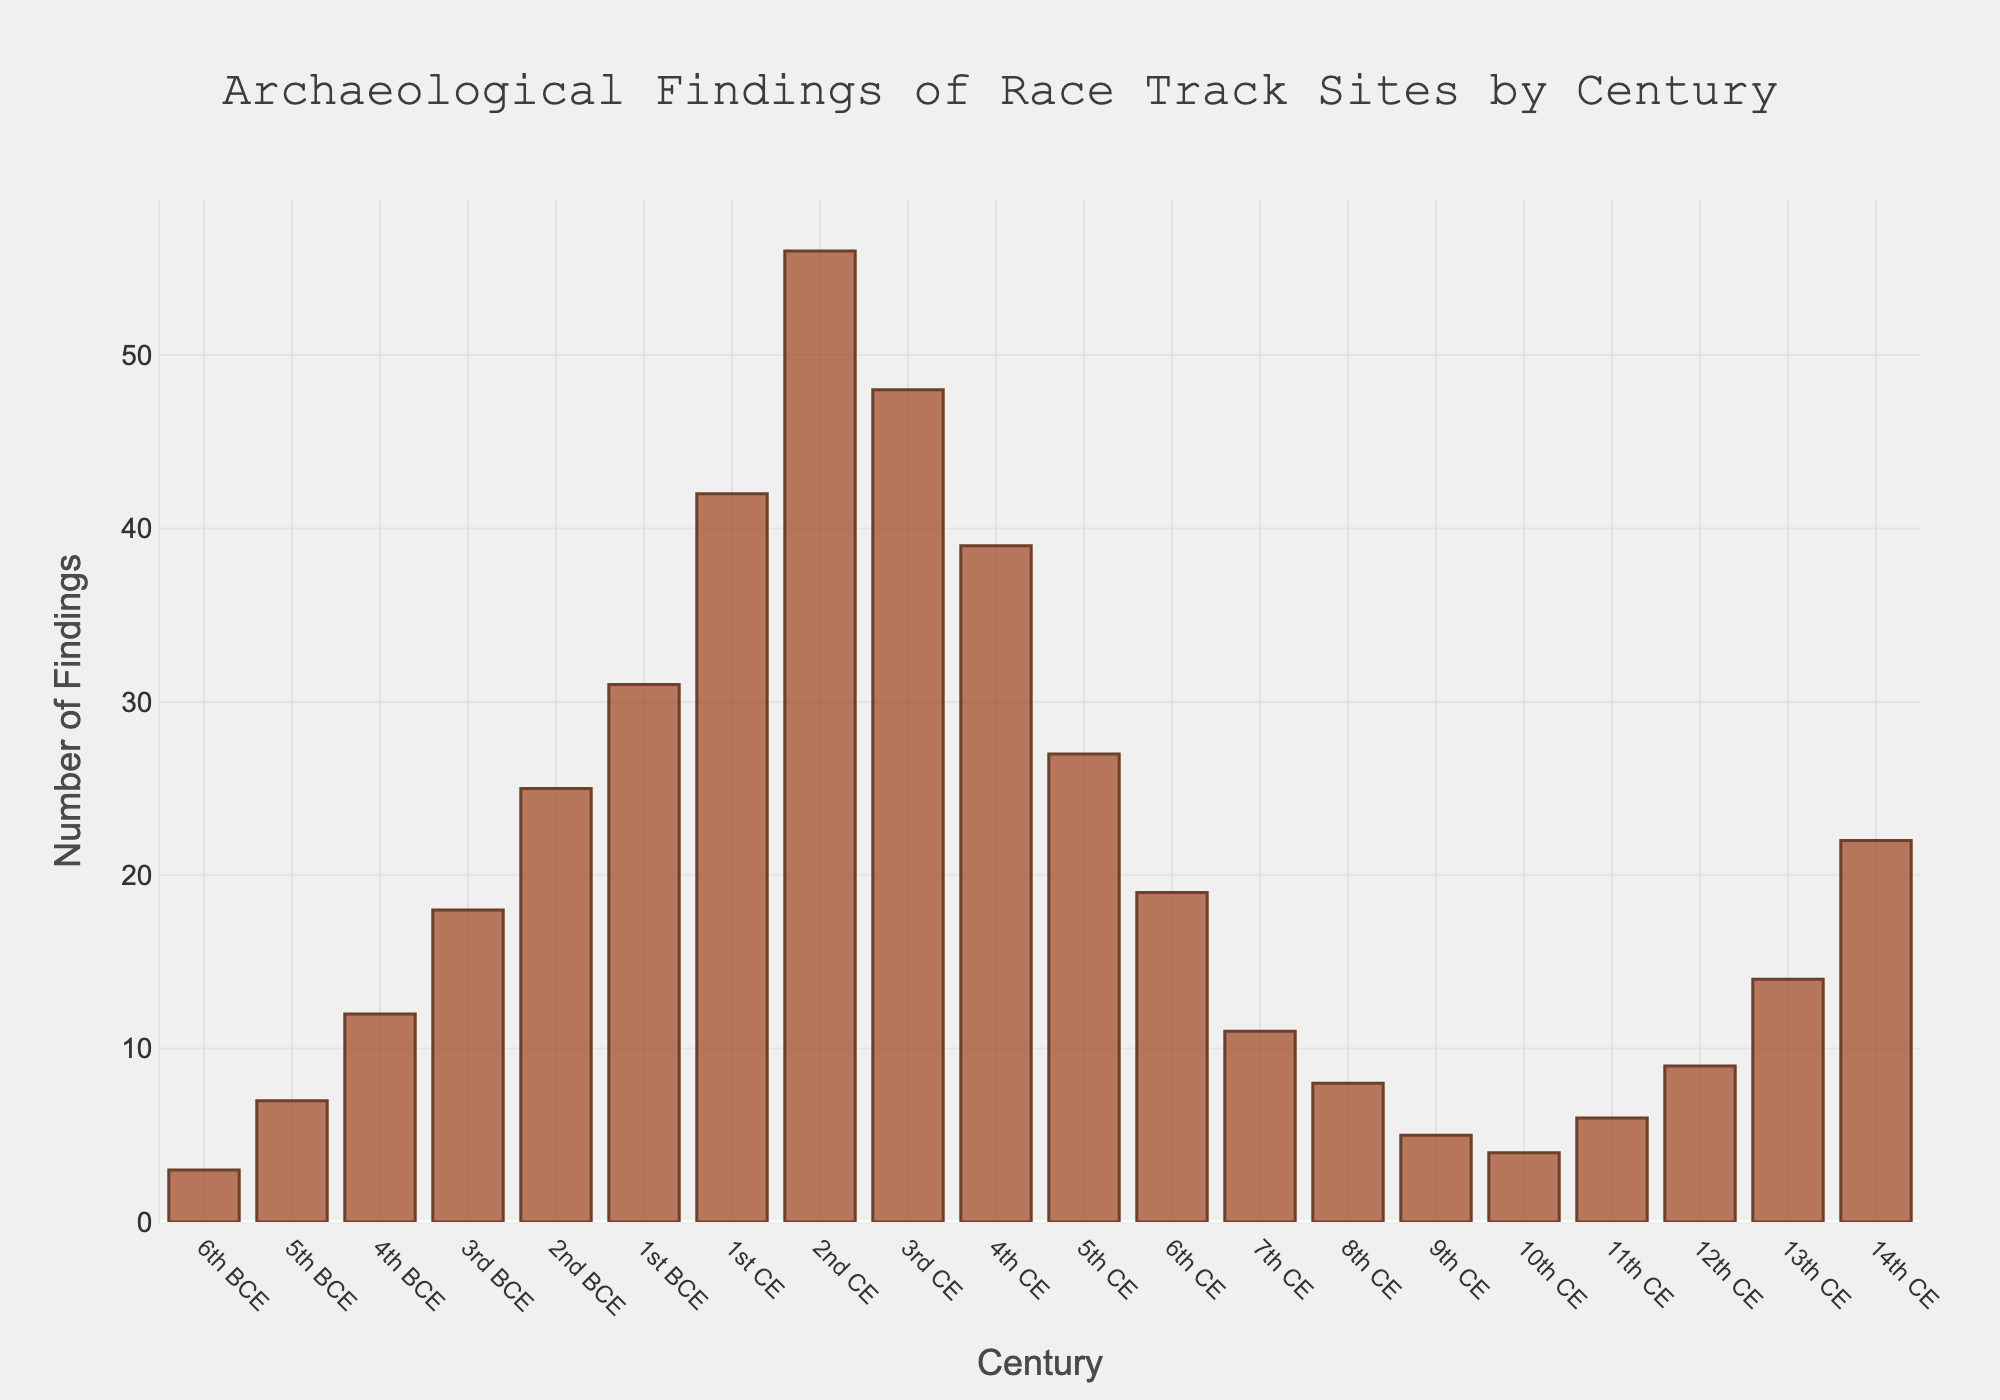What is the century with the highest number of archaeological findings? The century with the highest number of archaeological findings can be identified by finding the tallest bar in the chart. This is the 2nd CE with 56 findings.
Answer: 2nd CE Which century shows exactly 4 findings? To find the century with exactly 4 findings, look for the bar that reaches up to 4 on the y-axis. This is the 10th CE.
Answer: 10th CE What is the difference in the number of findings between the 1st CE and 3rd CE centuries? To find the difference, locate the bars for the 1st CE (42 findings) and 3rd CE (48 findings) and subtract the smaller number from the larger one: 48 - 42 = 6 findings.
Answer: 6 What is the sum of findings from the 6th BCE and 5th CE? Find the respective bars for the 6th BCE (3 findings) and 5th CE (27 findings), then add these numbers: 3 + 27 = 30 findings.
Answer: 30 Which century has fewer findings: the 8th CE or the 11th CE? Compare the heights of the bars for the 8th CE (8 findings) and the 11th CE (6 findings). The 11th CE has fewer findings.
Answer: 11th CE What is the average number of findings from the 4th BCE to the 2nd BCE? Find the total number of findings for the 4th BCE (12), 3rd BCE (18), and 2nd BCE (25). Their sum is 12 + 18 + 25 = 55. The average is 55 / 3 ≈ 18.33.
Answer: 18.33 How does the number of findings in the 14th CE compare to that in the 6th CE? Compare the heights of the bars for the 14th CE (22 findings) and the 6th CE (19 findings). The 14th CE has more findings.
Answer: 14th CE What is the trend in the number of findings from the 1st CE to the 3rd CE? Observing the three bars: 1st CE (42), 2nd CE (56), and 3rd CE (48), there is an increase from the 1st to the 2nd CE and a decrease from the 2nd to the 3rd CE.
Answer: Increase then decrease How many more findings are there in the 2nd CE compared to the 2nd BCE? Locate the bars for the 2nd CE (56 findings) and the 2nd BCE (25 findings). Subtract the findings of the 2nd BCE from the 2nd CE: 56 - 25 = 31.
Answer: 31 